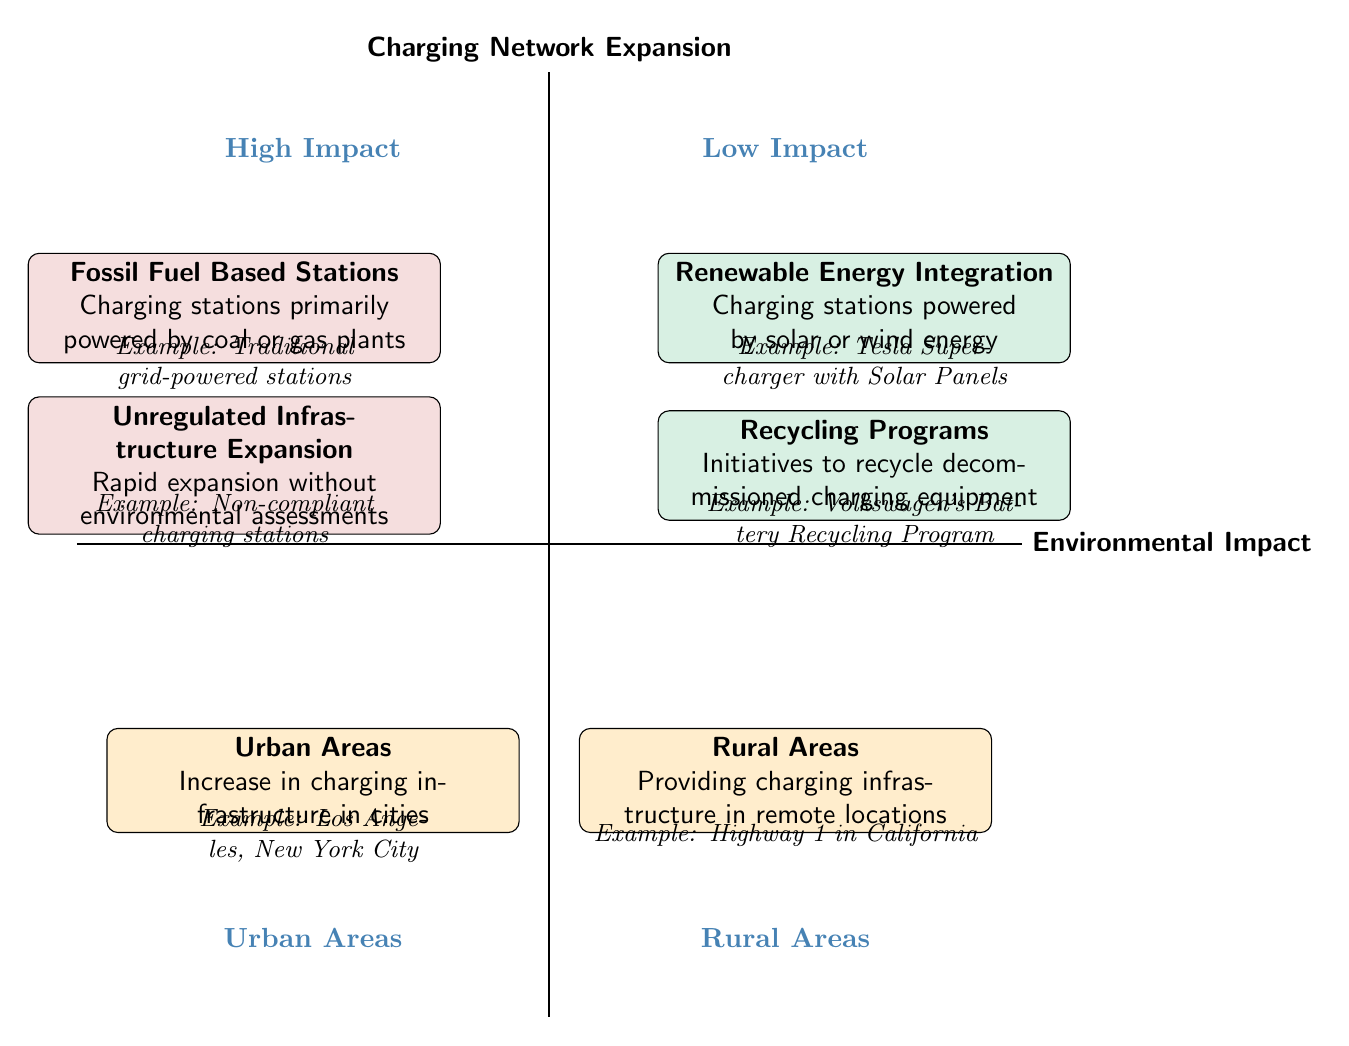What are the two categories of Environmental Impact represented in the diagram? The diagram divides Environmental Impact into two categories: Low Environmental Impact and High Environmental Impact, each occupying different areas of the chart.
Answer: Low Environmental Impact and High Environmental Impact What is one example of a Low Environmental Impact charging solution? The Low Environmental Impact area features several examples, one of which is the "Tesla Supercharger with Solar Panels" noted in the relevant node.
Answer: Tesla Supercharger with Solar Panels How many nodes represent Urban Areas in the diagram? There is one specific node labeled "Urban Areas" located in the quadrant that represents the impact on urban areas of charging network expansion.
Answer: 1 What type of charging station is classified as having High Environmental Impact? The High Environmental Impact quadrant includes the node titled "Fossil Fuel Based Stations," indicating a significant impact from these types of stations.
Answer: Fossil Fuel Based Stations Which node discusses providing charging infrastructure in remote locations? The node labeled "Rural Areas" specifically addresses the need for charging infrastructure in remote areas to support electric vehicle adoption.
Answer: Rural Areas What relationship can be inferred about Renewable Energy Integration and Urban Areas? Renewable Energy Integration, which is in the Low Environmental Impact category, can be related to Urban Areas since both are focused on promoting cleaner energy solutions and reducing emissions in cities.
Answer: Low Environmental Impact in Urban Areas How many total examples are provided for High Environmental Impact charging solutions? There are two distinct examples presented under the High Environmental Impact category, namely "Fossil Fuel Based Stations" and "Unregulated Infrastructure Expansion."
Answer: 2 What does the term "Unregulated Infrastructure Expansion" imply about charging stations? The term indicates that charging stations are being rapidly expanded without proper environmental assessments or sustainability plans, which can lead to significant negative impacts.
Answer: Rapid expansion without assessments What might be a consequence of expanding charging infrastructure in Urban Areas? The diagram suggests that increasing charging infrastructure in urban locations contributes to cleaner air and reduced noise pollution, which are positive outcomes of such expansion.
Answer: Cleaner air and reduced noise pollution 